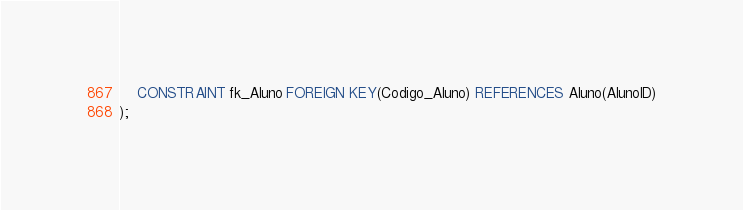Convert code to text. <code><loc_0><loc_0><loc_500><loc_500><_SQL_>	CONSTRAINT fk_Aluno FOREIGN KEY(Codigo_Aluno) REFERENCES Aluno(AlunoID)
);</code> 